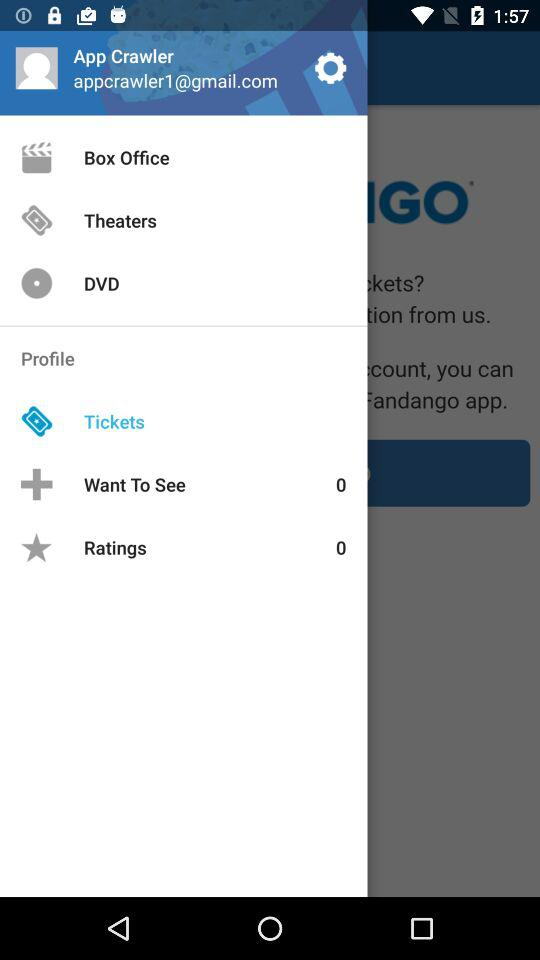What's the number of ratings? The number of ratings is 0. 